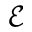<formula> <loc_0><loc_0><loc_500><loc_500>\mathcal { E }</formula> 